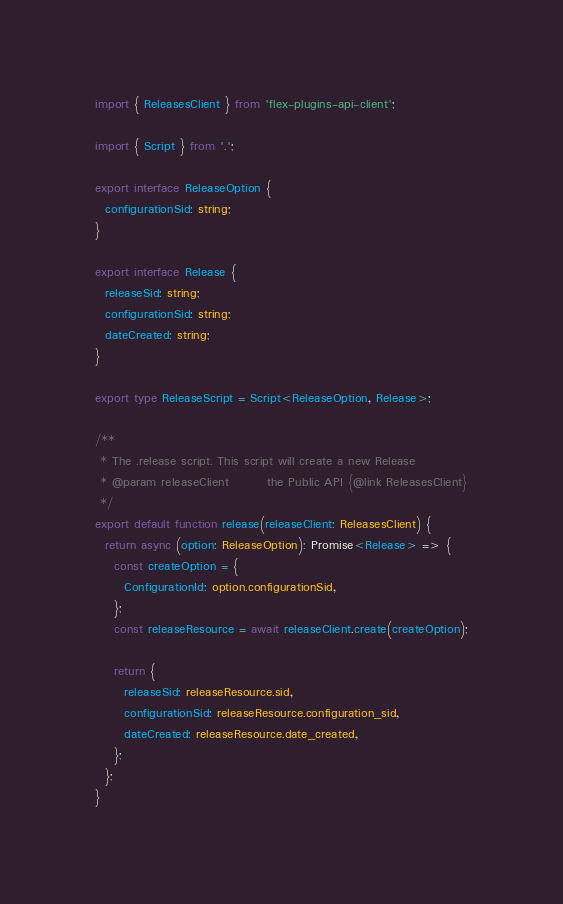Convert code to text. <code><loc_0><loc_0><loc_500><loc_500><_TypeScript_>import { ReleasesClient } from 'flex-plugins-api-client';

import { Script } from '.';

export interface ReleaseOption {
  configurationSid: string;
}

export interface Release {
  releaseSid: string;
  configurationSid: string;
  dateCreated: string;
}

export type ReleaseScript = Script<ReleaseOption, Release>;

/**
 * The .release script. This script will create a new Release
 * @param releaseClient        the Public API {@link ReleasesClient}
 */
export default function release(releaseClient: ReleasesClient) {
  return async (option: ReleaseOption): Promise<Release> => {
    const createOption = {
      ConfigurationId: option.configurationSid,
    };
    const releaseResource = await releaseClient.create(createOption);

    return {
      releaseSid: releaseResource.sid,
      configurationSid: releaseResource.configuration_sid,
      dateCreated: releaseResource.date_created,
    };
  };
}
</code> 